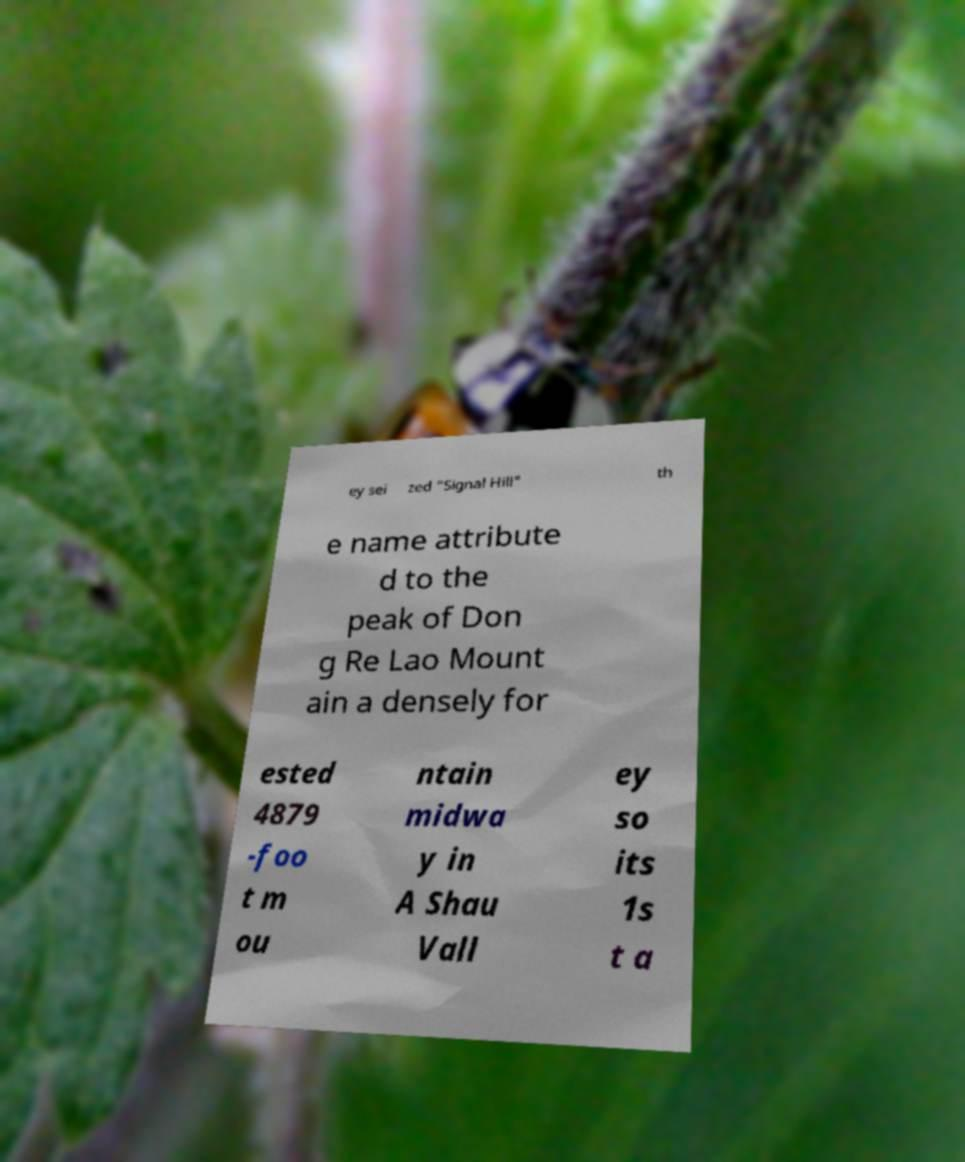For documentation purposes, I need the text within this image transcribed. Could you provide that? ey sei zed "Signal Hill" th e name attribute d to the peak of Don g Re Lao Mount ain a densely for ested 4879 -foo t m ou ntain midwa y in A Shau Vall ey so its 1s t a 